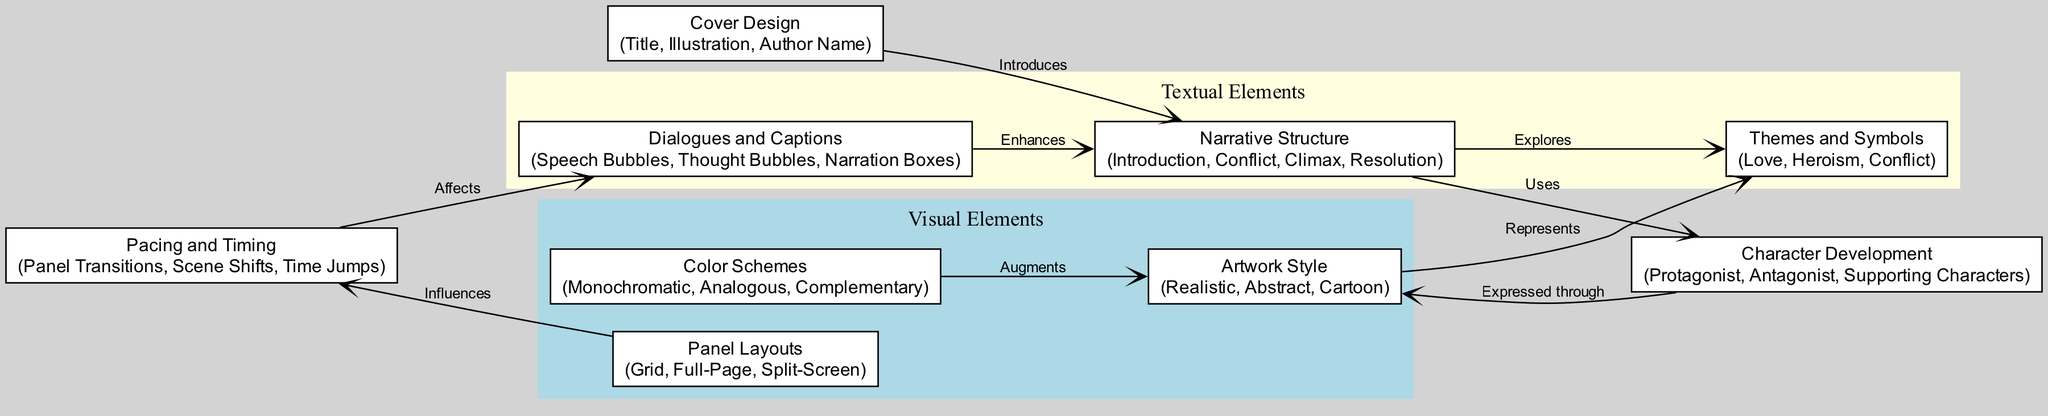What are the three main components of the narrative structure? The narrative structure includes three main components: Introduction, Conflict, Climax, and Resolution. From the diagram, we can see that these are labeled under the "Narrative Structure" node.
Answer: Introduction, Conflict, Climax, Resolution How many visual elements are identified in the diagram? The diagram identifies three visual elements within the "Visual Elements" subgraph: Panel Layouts, Artwork Style, and Color Schemes. Summing these gives a total of three visual elements.
Answer: 3 What type of dialogue enhances the narrative structure? The dialogue in the diagram that enhances narrative structure is categorized as "Dialogues and Captions." It specifically mentions Speech Bubbles, Thought Bubbles, and Narration Boxes, indicating their role in enriching the narrative.
Answer: Dialogues and Captions Which visual element influences pacing and timing? From the diagram, it’s clear that Panel Layouts influence Pacing and Timing, as indicated by the connecting edge labeled "Influences." This relationship shows how the arrangement of panels can affect the reading experience.
Answer: Panel Layouts How do themes and symbols relate to artwork style? The relationship between Themes and Symbols (Love, Heroism, Conflict) and Artwork Style (Realistic, Abstract, Cartoon) is shown through the edge labeled "Represents." This indicates that the style of artwork can depict the underlying themes within the graphic novel.
Answer: Represents What is the role of cover design in the narrative structure? The cover design plays an introductory role in the narrative structure, as denoted by the edge labeled "Introduces." This suggests that the design elements like the title, illustration, and author name serve to set up the narrative before the reader engages with the content.
Answer: Introduces What type of characters are included in character development? The character development within the diagram includes Protagonist, Antagonist, and Supporting Characters. These roles are essential for building the narrative and are highlighted in the "Character Development" node.
Answer: Protagonist, Antagonist, Supporting Characters How does artwork style express character development? The diagram shows that character development is expressed through Artwork Style, indicated by the edge labeled "Expressed through." This implies that the way characters are illustrated directly impacts how they are perceived and developed throughout the narrative.
Answer: Expressed through 